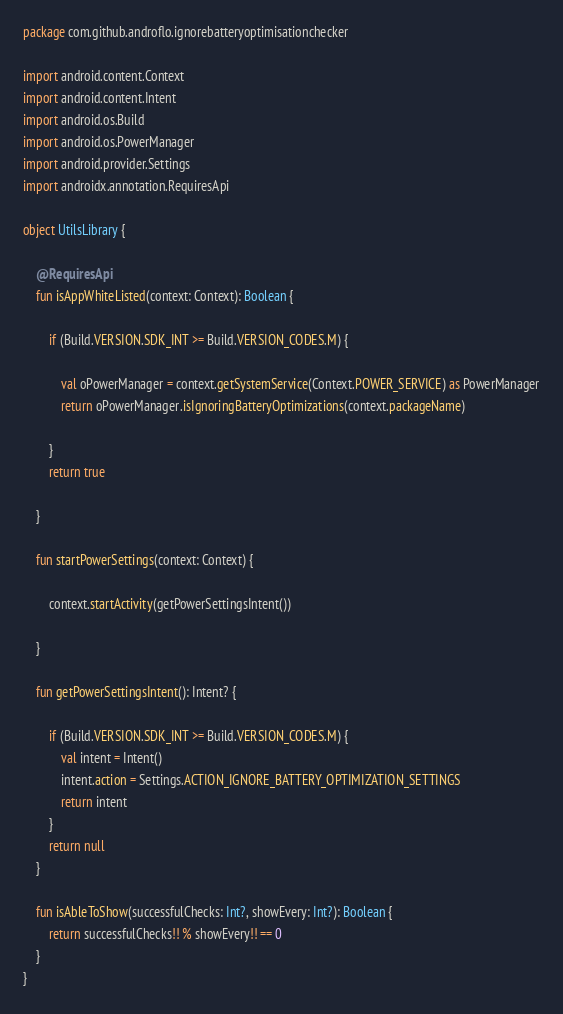Convert code to text. <code><loc_0><loc_0><loc_500><loc_500><_Kotlin_>package com.github.androflo.ignorebatteryoptimisationchecker

import android.content.Context
import android.content.Intent
import android.os.Build
import android.os.PowerManager
import android.provider.Settings
import androidx.annotation.RequiresApi

object UtilsLibrary {

    @RequiresApi
    fun isAppWhiteListed(context: Context): Boolean {

        if (Build.VERSION.SDK_INT >= Build.VERSION_CODES.M) {

            val oPowerManager = context.getSystemService(Context.POWER_SERVICE) as PowerManager
            return oPowerManager.isIgnoringBatteryOptimizations(context.packageName)

        }
        return true

    }

    fun startPowerSettings(context: Context) {

        context.startActivity(getPowerSettingsIntent())

    }

    fun getPowerSettingsIntent(): Intent? {

        if (Build.VERSION.SDK_INT >= Build.VERSION_CODES.M) {
            val intent = Intent()
            intent.action = Settings.ACTION_IGNORE_BATTERY_OPTIMIZATION_SETTINGS
            return intent
        }
        return null
    }

    fun isAbleToShow(successfulChecks: Int?, showEvery: Int?): Boolean {
        return successfulChecks!! % showEvery!! == 0
    }
}</code> 